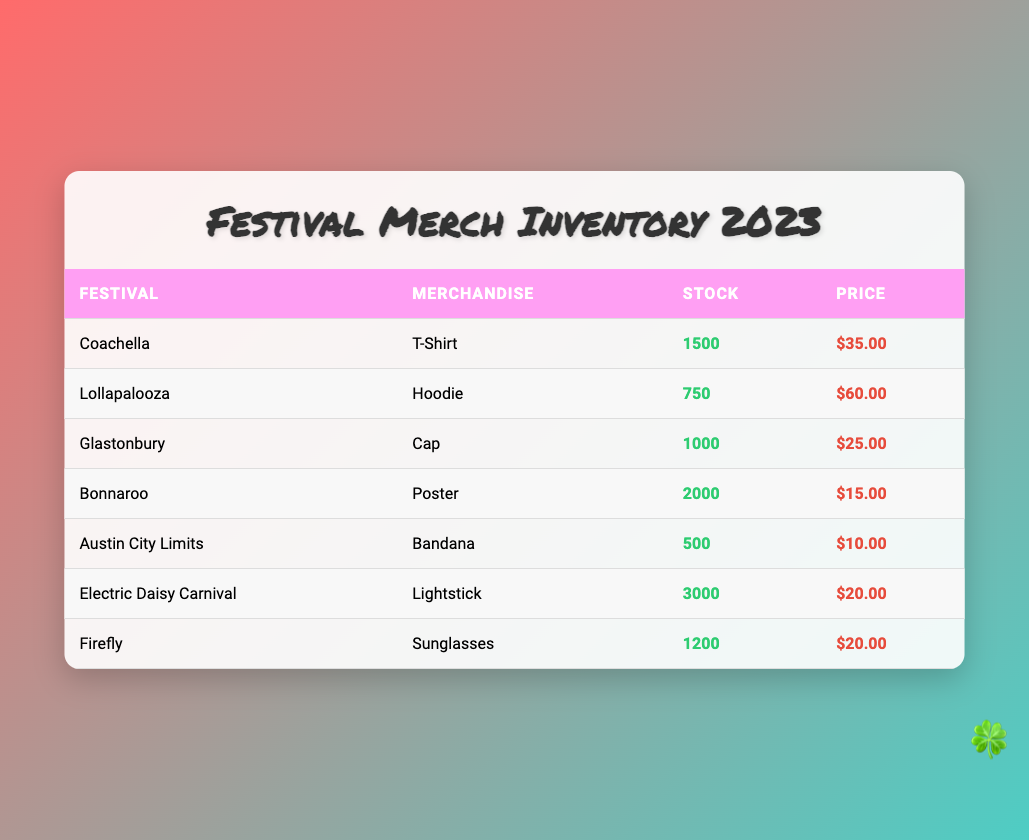What's the stock level of T-Shirts at Coachella? The table lists the stock level for T-Shirts at Coachella, which can be found in the "Stock" column for the row with "Coachella" under the "Festival" column. The value there is 1500.
Answer: 1500 How much does a Hoodie cost at Lollapalooza? The price per Hoodie at Lollapalooza is indicated in the "Price" column for the row corresponding to Lollapalooza. The price listed is $60.00.
Answer: $60.00 Which festival has the highest stock level of merchandise? To find which festival has the highest stock level, we compare the "Stock" values across all rows. The highest stock level is 3000 for Electric Daisy Carnival.
Answer: Electric Daisy Carnival What is the total stock of merchandise across all festivals? We need to sum the stock levels of all the merchandise listed in the "Stock" column. The values to sum are 1500 (Coachella) + 750 (Lollapalooza) + 1000 (Glastonbury) + 2000 (Bonnaroo) + 500 (Austin City Limits) + 3000 (Electric Daisy Carnival) + 1200 (Firefly), which totals to 10000.
Answer: 10000 Is the stock level of Sunglasses at Firefly more than the stock level of Bandanas at Austin City Limits? We check the "Stock" value for Sunglasses at Firefly (1200) and for Bandanas at Austin City Limits (500). Since 1200 is greater than 500, the statement is true.
Answer: Yes What is the average price of merchandise for all festivals? To find the average price, we sum all the prices: $35.00 (T-Shirt) + $60.00 (Hoodie) + $25.00 (Cap) + $15.00 (Poster) + $10.00 (Bandana) + $20.00 (Lightstick) + $20.00 (Sunglasses), which equals $175.00. Dividing by the number of merchandise types (7), the average price is $175.00 / 7 = $25.00.
Answer: $25.00 Which merchandise has the lowest stock level? We compare the "Stock" values for each merchandise type in the table. The lowest stock level is 500 for the Bandana at Austin City Limits.
Answer: Bandana If I want to buy one of each merchandise type, what will be the total cost? We will add the price of each merchandise type: $35.00 (T-Shirt) + $60.00 (Hoodie) + $25.00 (Cap) + $15.00 (Poster) + $10.00 (Bandana) + $20.00 (Lightstick) + $20.00 (Sunglasses), which totals $175.00.
Answer: $175.00 